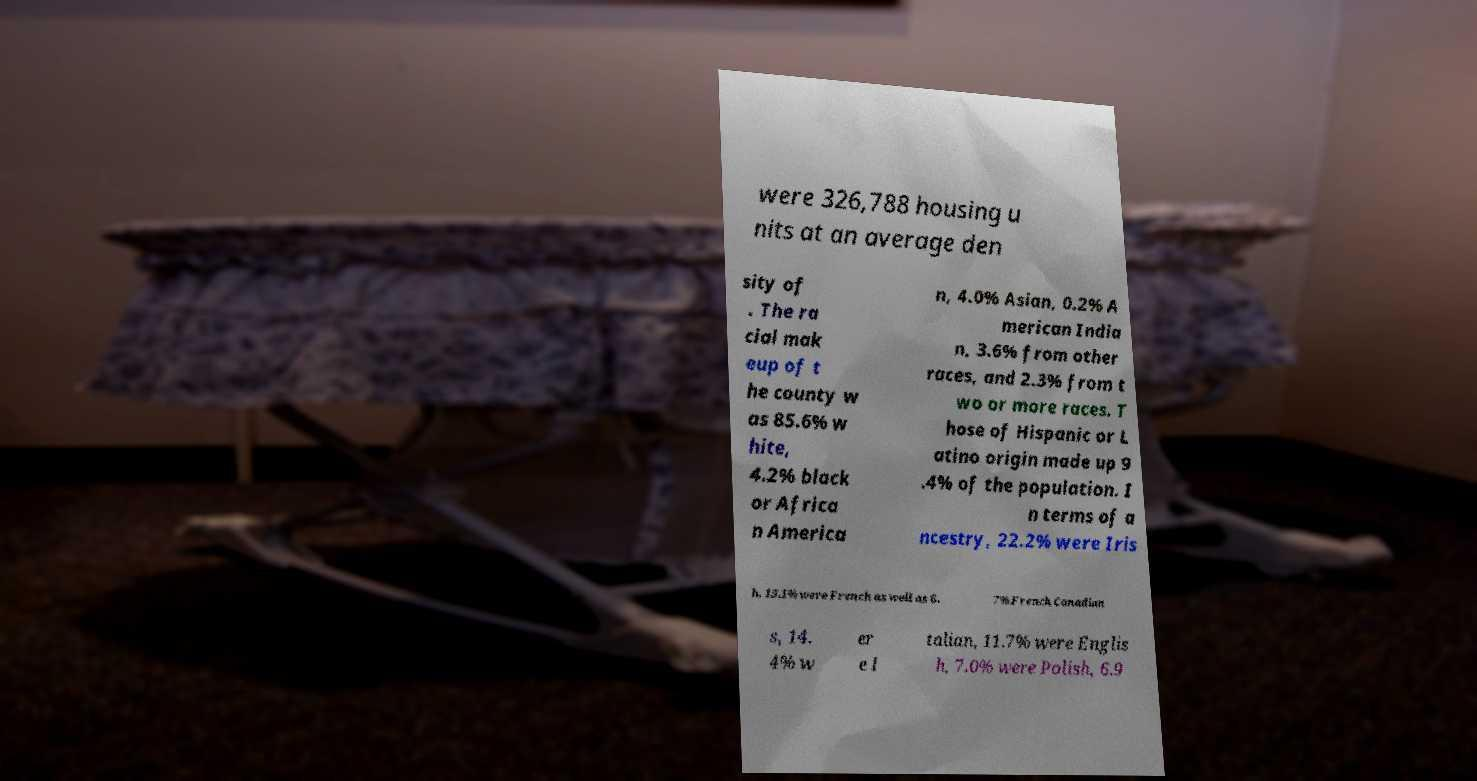Can you read and provide the text displayed in the image?This photo seems to have some interesting text. Can you extract and type it out for me? were 326,788 housing u nits at an average den sity of . The ra cial mak eup of t he county w as 85.6% w hite, 4.2% black or Africa n America n, 4.0% Asian, 0.2% A merican India n, 3.6% from other races, and 2.3% from t wo or more races. T hose of Hispanic or L atino origin made up 9 .4% of the population. I n terms of a ncestry, 22.2% were Iris h, 15.1% were French as well as 6. 7% French Canadian s, 14. 4% w er e I talian, 11.7% were Englis h, 7.0% were Polish, 6.9 